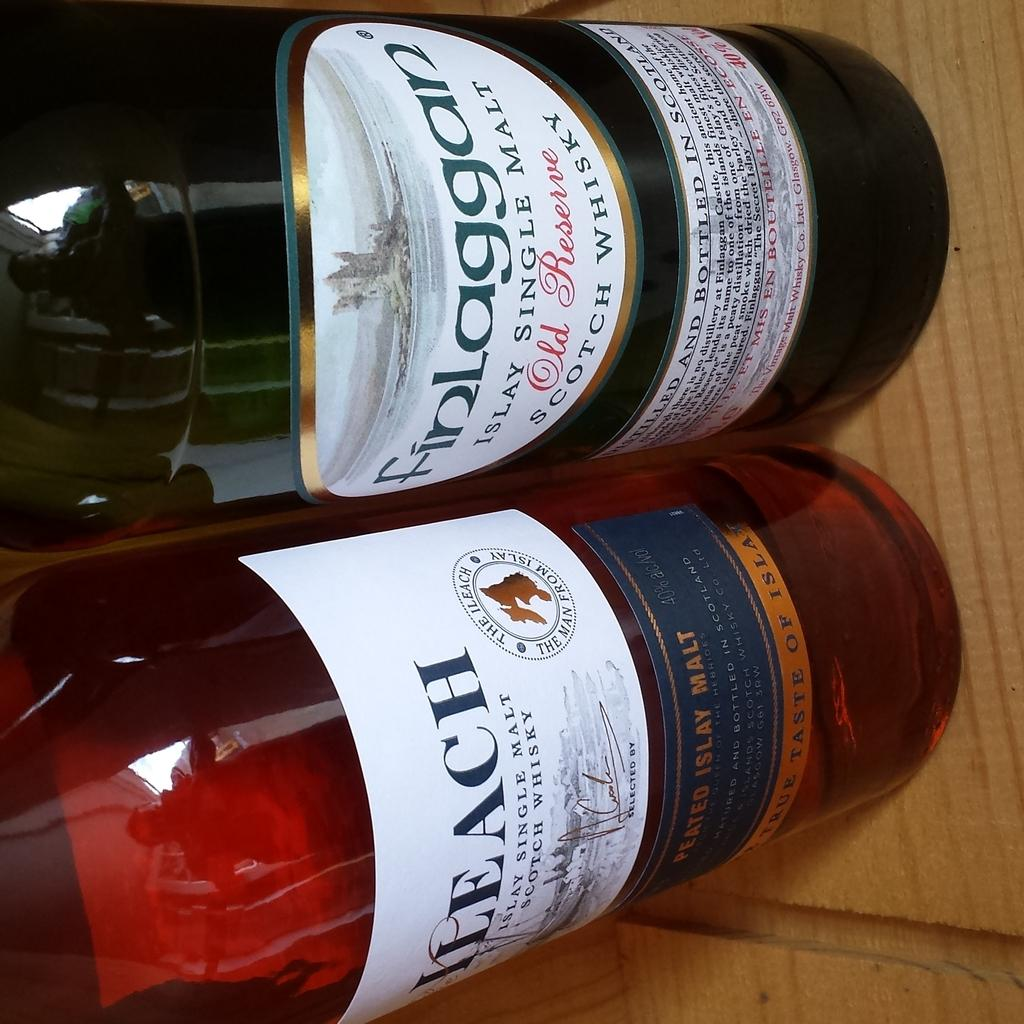<image>
Write a terse but informative summary of the picture. A bottle of Finlaggan next to another bottle. 